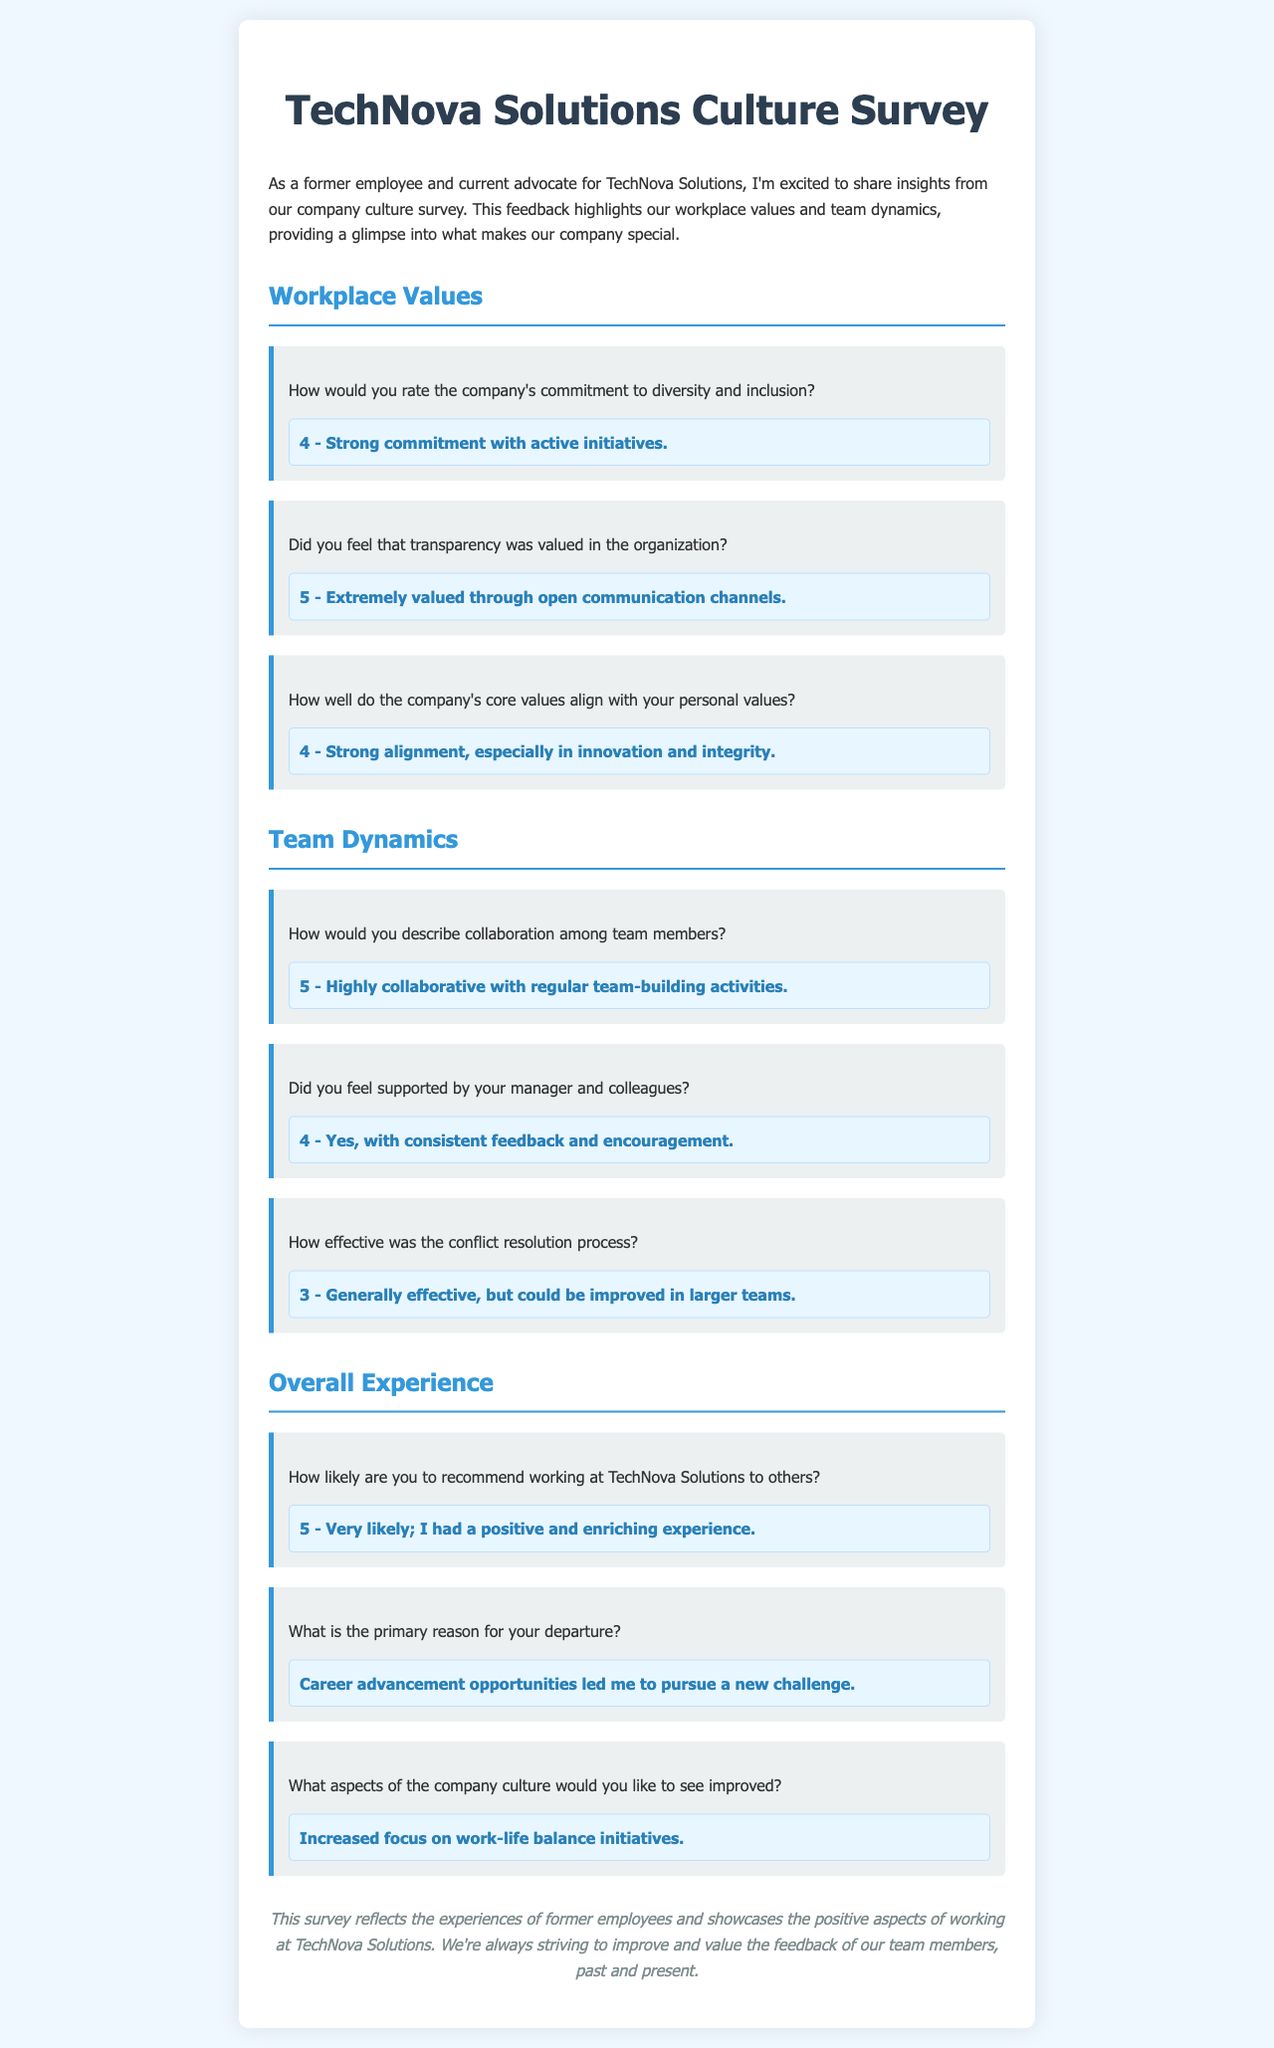How would you rate the company's commitment to diversity and inclusion? The response to this question reflects the level of commitment indicated by former employees, which is a rating scale value.
Answer: 4 - Strong commitment with active initiatives Did you feel that transparency was valued in the organization? This question explores employee perceptions of transparency within the company, as rated by former employees.
Answer: 5 - Extremely valued through open communication channels How would you describe collaboration among team members? The effectiveness of team collaboration is evaluated here, based on the feedback from employees.
Answer: 5 - Highly collaborative with regular team-building activities How likely are you to recommend working at TechNova Solutions to others? This question gauges overall satisfaction and willingness to recommend the company to others based on surveys.
Answer: 5 - Very likely; I had a positive and enriching experience What aspects of the company culture would you like to see improved? This response identifies specific areas of improvement as suggested by former employees regarding company culture.
Answer: Increased focus on work-life balance initiatives 